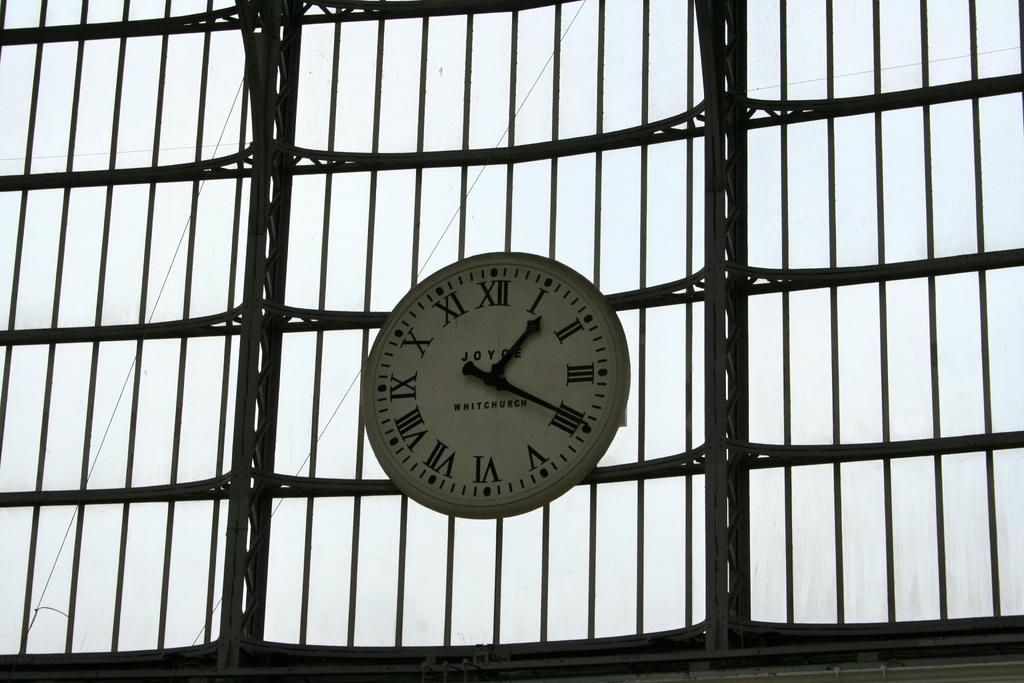<image>
Summarize the visual content of the image. A Joyce Whitchurch clock on a fence has the time of 1:19. 